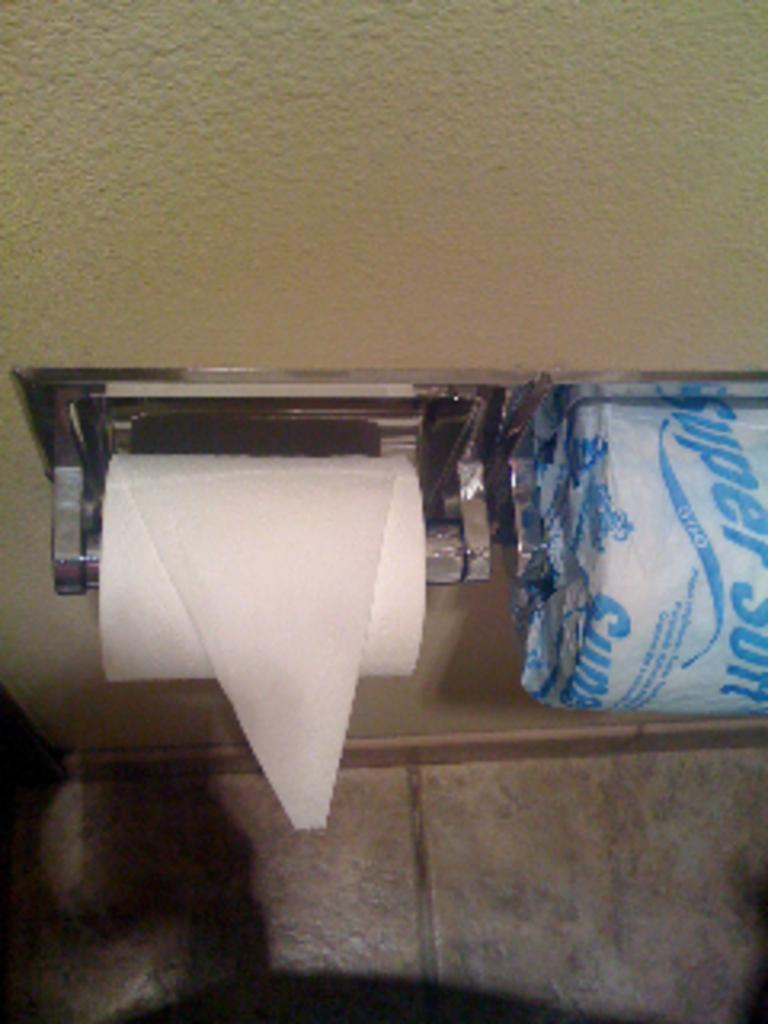<image>
Summarize the visual content of the image. A toilet paper wrapper shows the word Super at an angle. 